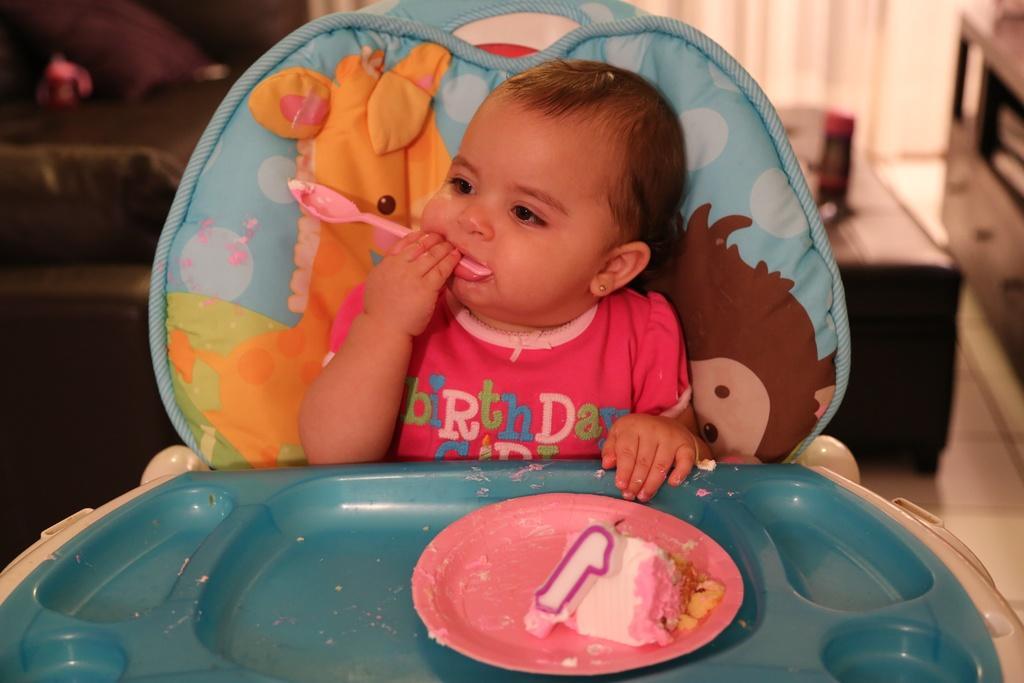Can you describe this image briefly? In this image there is a baby sitting on the baby chair. In front of her there is a table. On top of it there is a food item in a plate. There is a candle. There is a spoon in her mouth. On the right side of the image there is a wooden table. In front of that there is another table. On top of it there is some object. There are curtains. 